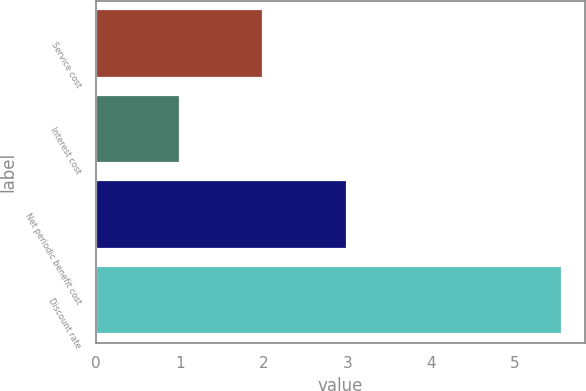Convert chart to OTSL. <chart><loc_0><loc_0><loc_500><loc_500><bar_chart><fcel>Service cost<fcel>Interest cost<fcel>Net periodic benefit cost<fcel>Discount rate<nl><fcel>2<fcel>1<fcel>3<fcel>5.56<nl></chart> 